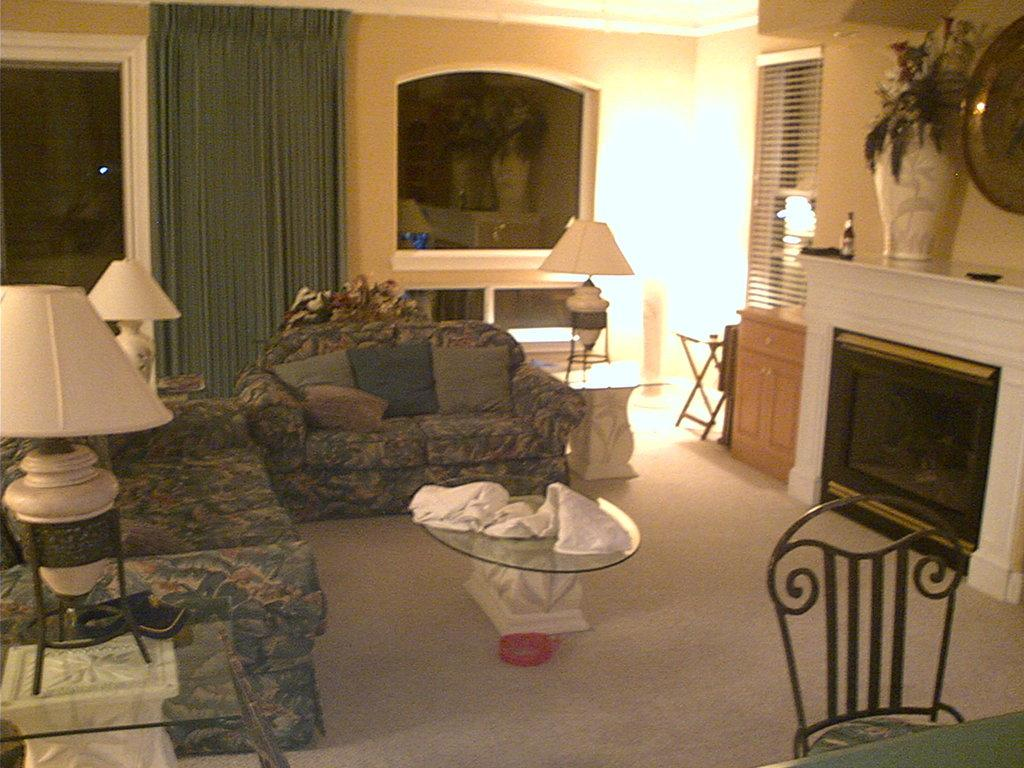What type of room is depicted in the image? The image appears to be taken in a living room. What type of furniture can be seen in the living room? There is a sofa set and chairs in the image. Where is the teapoy located in the image? The teapoy is on the left side of the image. What is placed on the right side of the image? There is a flower vase on the right side of the image. What is used to illuminate the room in the image? There are lights in the image. What type of invention is being used by the zebra in the image? There is no zebra present in the image, so it is not possible to determine what invention might be used by a zebra. 